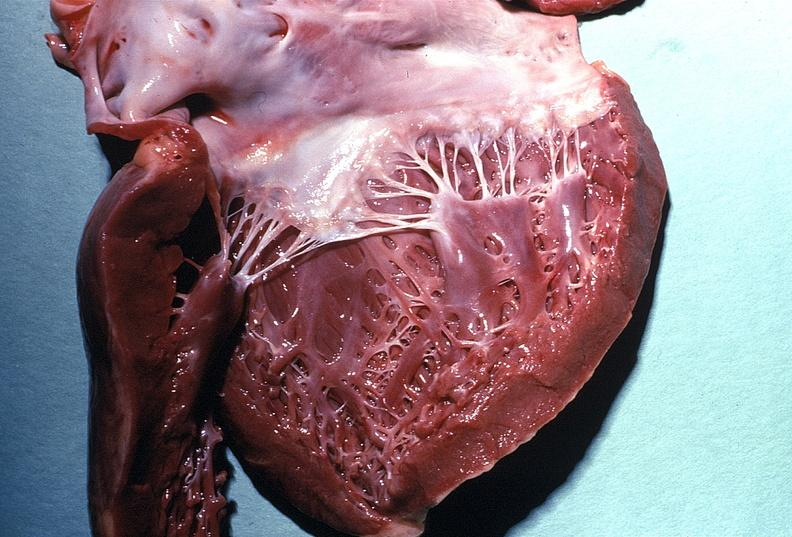what does this image show?
Answer the question using a single word or phrase. Normal mitral valve 